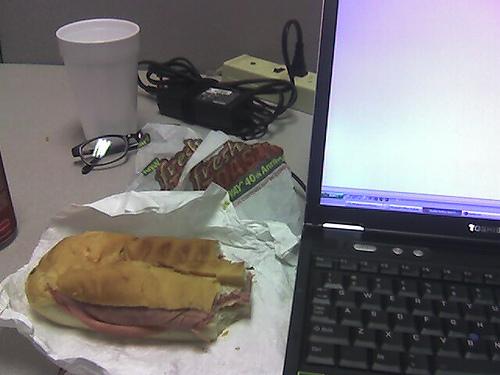What was the sandwich wrapped in?
Keep it brief. Paper. What is plugged in?
Keep it brief. Laptop. What is half eaten?
Answer briefly. Sandwich. 